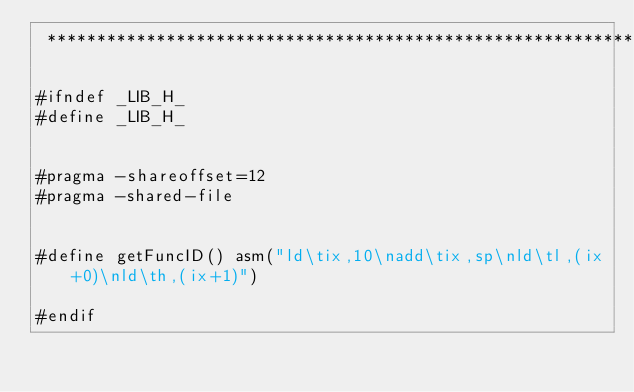Convert code to text. <code><loc_0><loc_0><loc_500><loc_500><_C_> ****************************************************************/

#ifndef _LIB_H_
#define _LIB_H_


#pragma -shareoffset=12
#pragma -shared-file


#define getFuncID() asm("ld\tix,10\nadd\tix,sp\nld\tl,(ix+0)\nld\th,(ix+1)")

#endif
</code> 